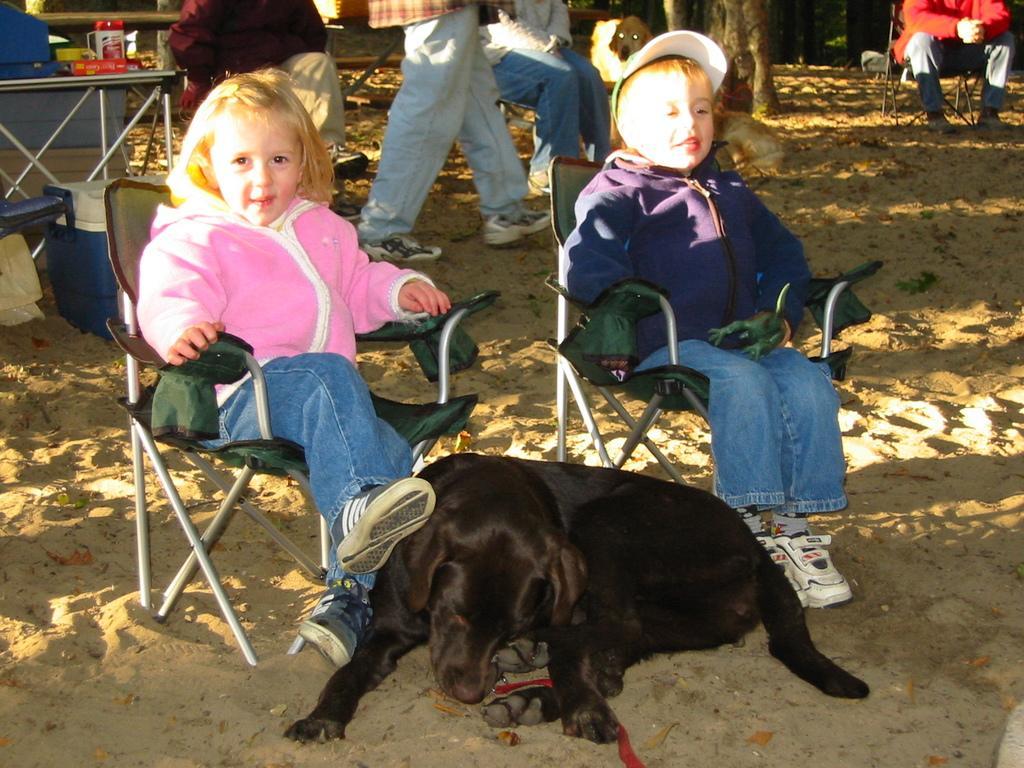Can you describe this image briefly? In this picture I can see couple of kids seated on the chairs and I can see a black color dog and a man walking and few of them seated on the back and I can see a cup and few items on the table and I can see a plastic box on the ground. 